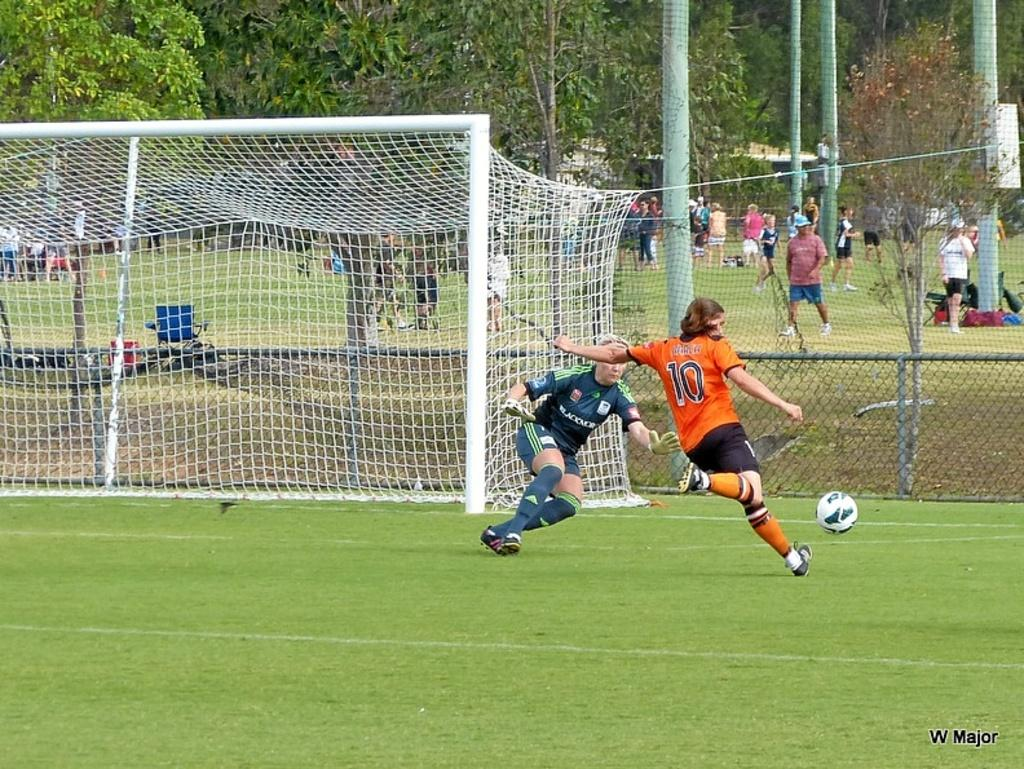Provide a one-sentence caption for the provided image. W major wrote on the bottom left of a soccer picture. 